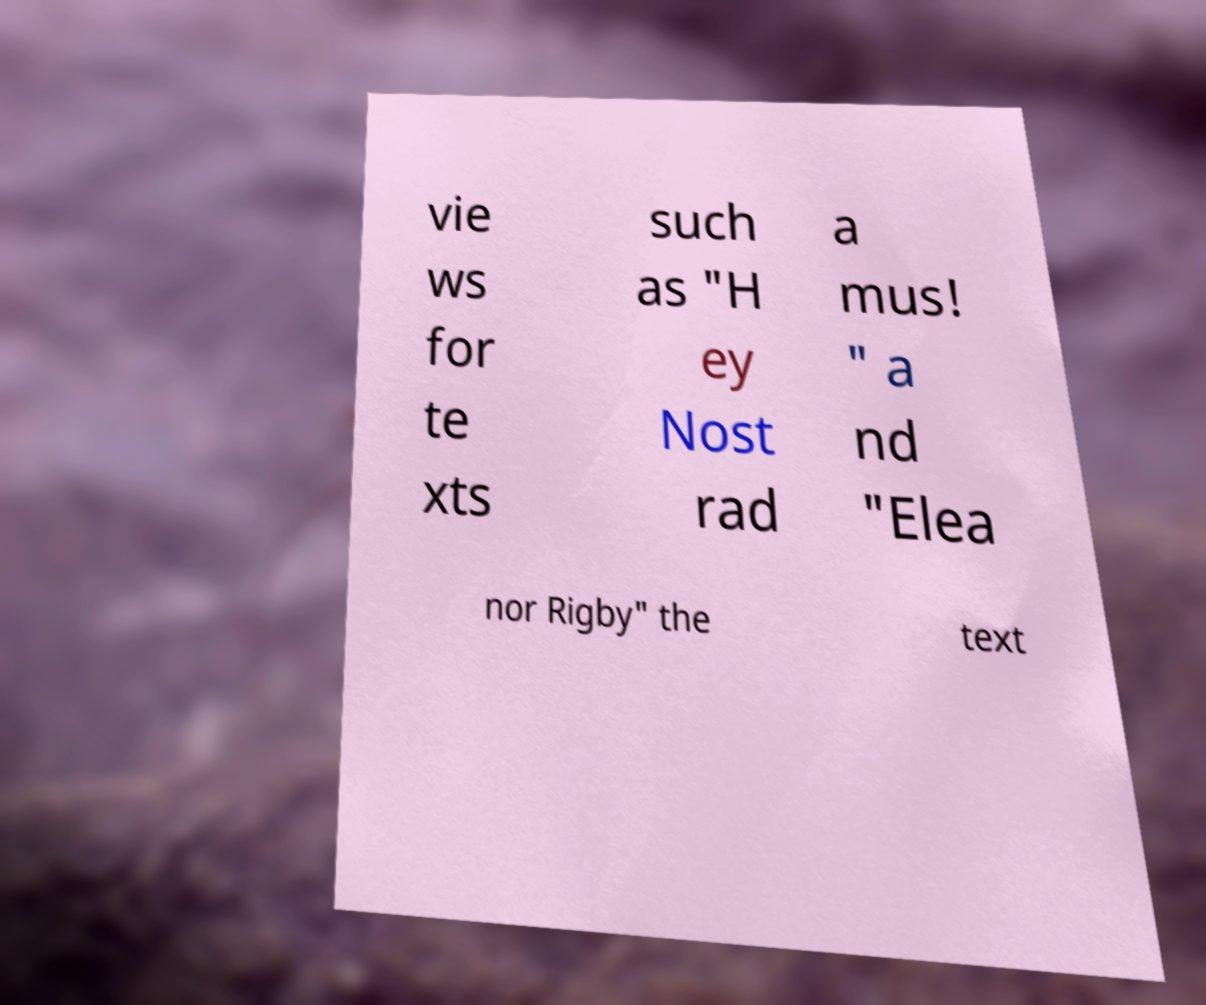Can you accurately transcribe the text from the provided image for me? vie ws for te xts such as "H ey Nost rad a mus! " a nd "Elea nor Rigby" the text 